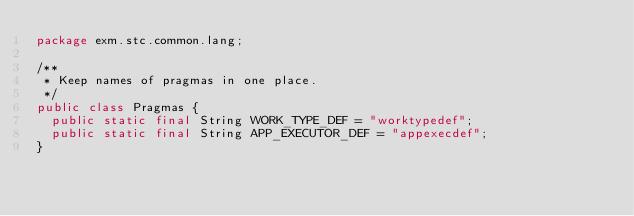<code> <loc_0><loc_0><loc_500><loc_500><_Java_>package exm.stc.common.lang;

/**
 * Keep names of pragmas in one place.
 */
public class Pragmas {
  public static final String WORK_TYPE_DEF = "worktypedef";
  public static final String APP_EXECUTOR_DEF = "appexecdef";
}
</code> 